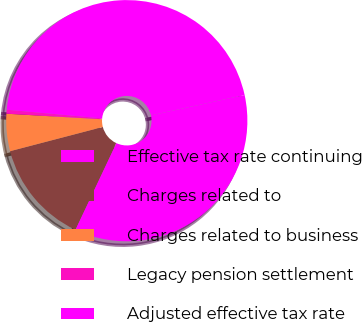Convert chart to OTSL. <chart><loc_0><loc_0><loc_500><loc_500><pie_chart><fcel>Effective tax rate continuing<fcel>Charges related to<fcel>Charges related to business<fcel>Legacy pension settlement<fcel>Adjusted effective tax rate<nl><fcel>35.44%<fcel>13.91%<fcel>4.99%<fcel>0.53%<fcel>45.13%<nl></chart> 